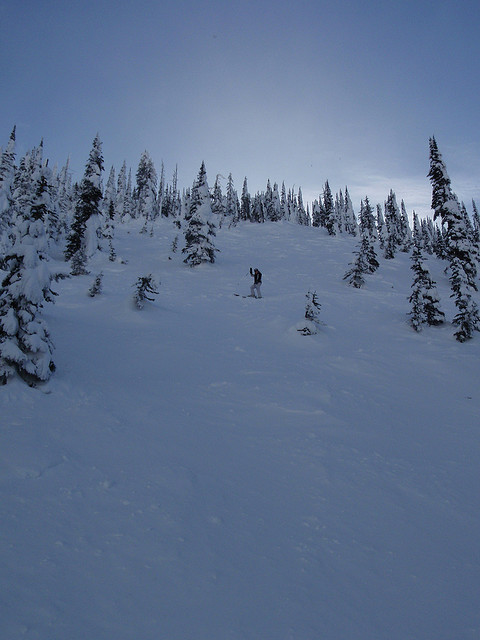How does this snowboarding scene compare to typical ski resort conditions? This scene offers a more secluded and natural environment compared to the groomed trails commonly found at ski resorts. The unmarked slope surrounded by dense forests suggests a backcountry setting, appealing to those seeking a more adventurous and less crowded snowboarding experience. 